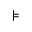Convert formula to latex. <formula><loc_0><loc_0><loc_500><loc_500>\models</formula> 